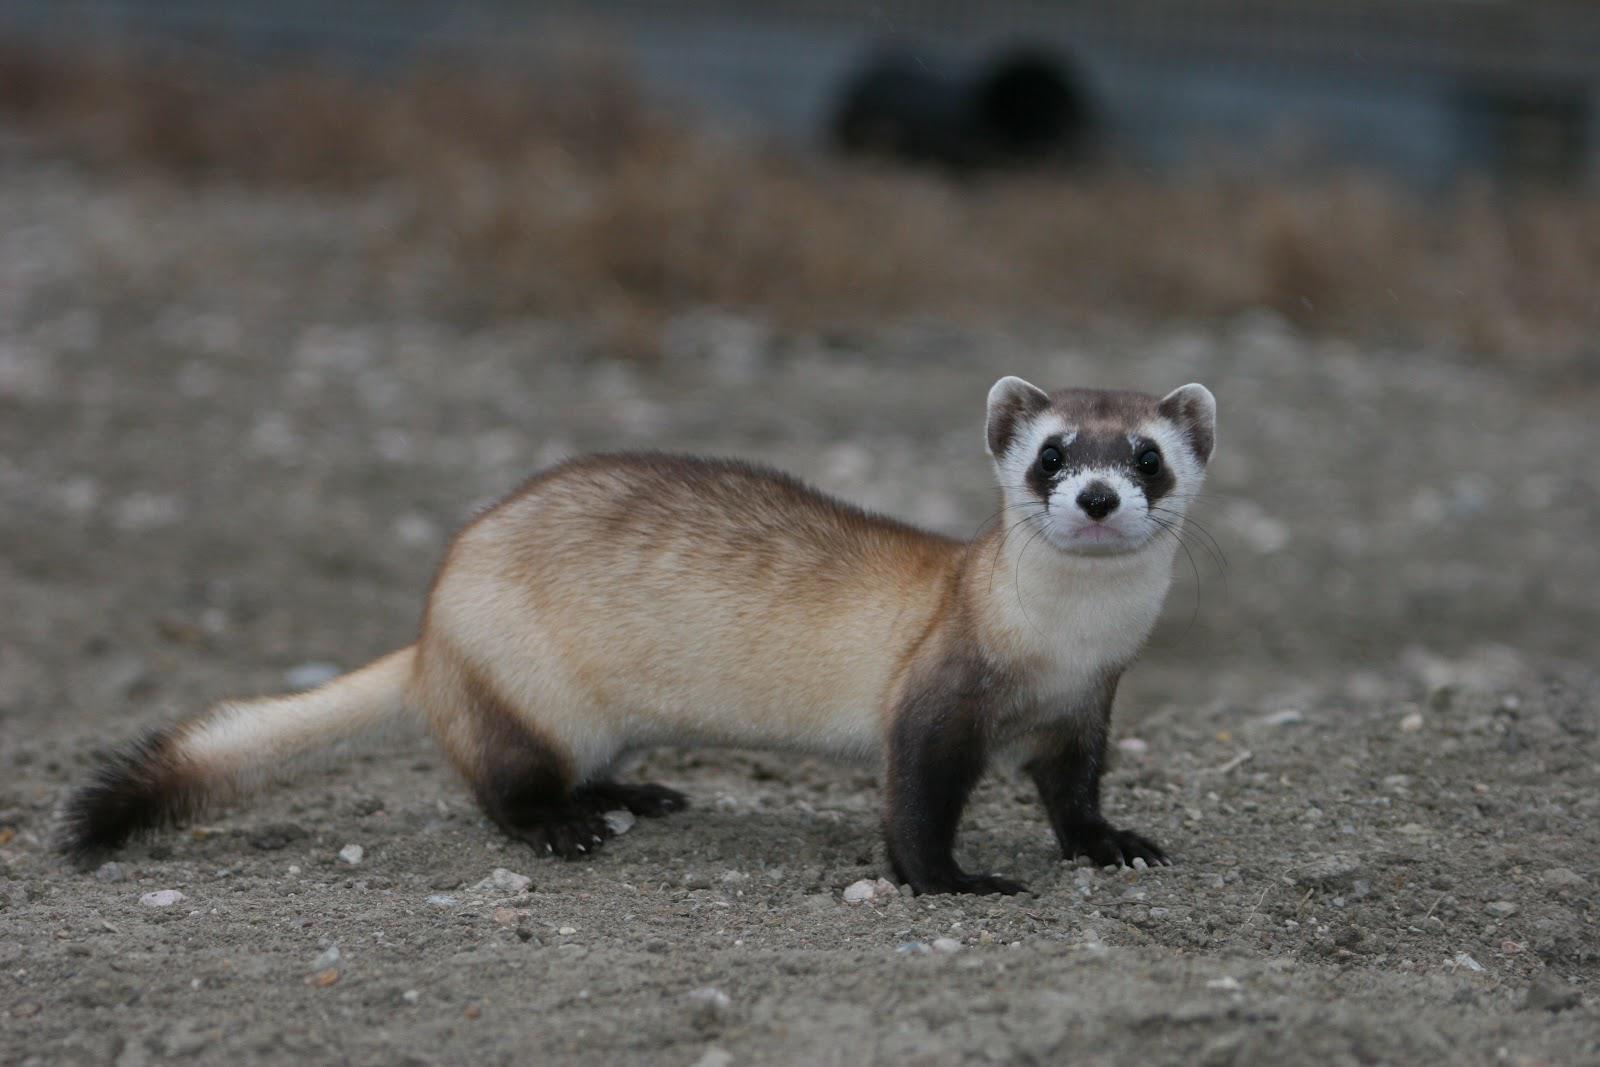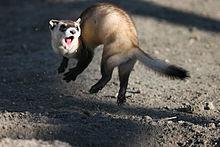The first image is the image on the left, the second image is the image on the right. Considering the images on both sides, is "There are at least two animals in the image on the right." valid? Answer yes or no. No. 